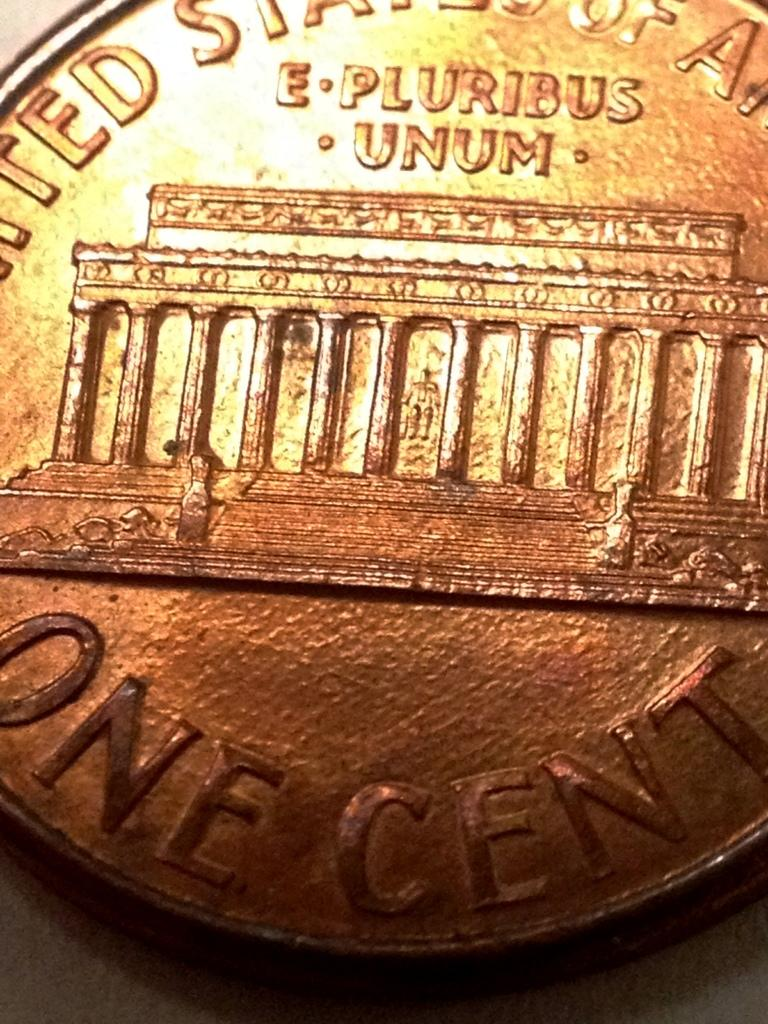<image>
Offer a succinct explanation of the picture presented. A coin with E Pluribus Unum on it with a building under it. 